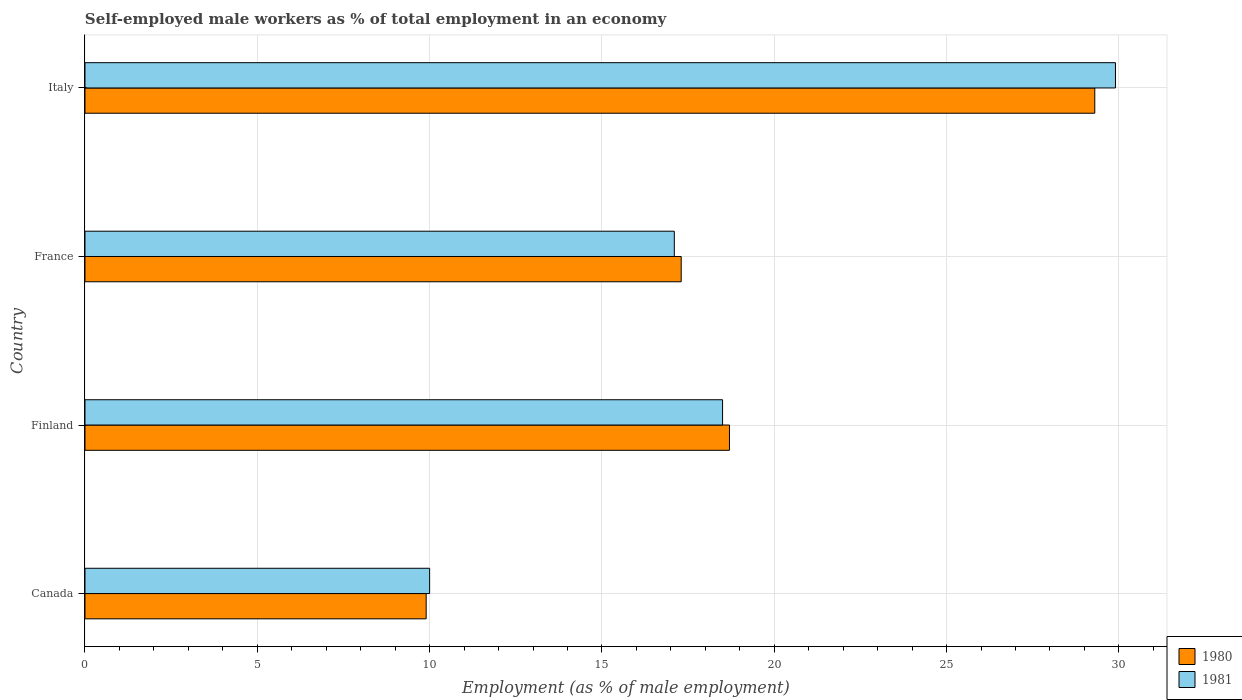How many different coloured bars are there?
Offer a terse response. 2. How many groups of bars are there?
Keep it short and to the point. 4. How many bars are there on the 2nd tick from the bottom?
Ensure brevity in your answer.  2. Across all countries, what is the maximum percentage of self-employed male workers in 1981?
Keep it short and to the point. 29.9. Across all countries, what is the minimum percentage of self-employed male workers in 1981?
Provide a short and direct response. 10. What is the total percentage of self-employed male workers in 1981 in the graph?
Offer a very short reply. 75.5. What is the difference between the percentage of self-employed male workers in 1981 in Canada and that in Finland?
Your response must be concise. -8.5. What is the difference between the percentage of self-employed male workers in 1981 in Italy and the percentage of self-employed male workers in 1980 in France?
Keep it short and to the point. 12.6. What is the average percentage of self-employed male workers in 1980 per country?
Your response must be concise. 18.8. What is the difference between the percentage of self-employed male workers in 1981 and percentage of self-employed male workers in 1980 in Canada?
Provide a short and direct response. 0.1. What is the ratio of the percentage of self-employed male workers in 1980 in Canada to that in France?
Ensure brevity in your answer.  0.57. What is the difference between the highest and the second highest percentage of self-employed male workers in 1980?
Offer a very short reply. 10.6. What is the difference between the highest and the lowest percentage of self-employed male workers in 1980?
Make the answer very short. 19.4. In how many countries, is the percentage of self-employed male workers in 1980 greater than the average percentage of self-employed male workers in 1980 taken over all countries?
Give a very brief answer. 1. Is the sum of the percentage of self-employed male workers in 1981 in Canada and Finland greater than the maximum percentage of self-employed male workers in 1980 across all countries?
Offer a terse response. No. What does the 1st bar from the top in France represents?
Offer a very short reply. 1981. How many countries are there in the graph?
Ensure brevity in your answer.  4. What is the difference between two consecutive major ticks on the X-axis?
Your response must be concise. 5. Are the values on the major ticks of X-axis written in scientific E-notation?
Offer a very short reply. No. Does the graph contain grids?
Offer a terse response. Yes. How are the legend labels stacked?
Offer a very short reply. Vertical. What is the title of the graph?
Keep it short and to the point. Self-employed male workers as % of total employment in an economy. Does "1990" appear as one of the legend labels in the graph?
Your answer should be compact. No. What is the label or title of the X-axis?
Offer a terse response. Employment (as % of male employment). What is the Employment (as % of male employment) of 1980 in Canada?
Offer a terse response. 9.9. What is the Employment (as % of male employment) in 1980 in Finland?
Your response must be concise. 18.7. What is the Employment (as % of male employment) in 1981 in Finland?
Keep it short and to the point. 18.5. What is the Employment (as % of male employment) of 1980 in France?
Ensure brevity in your answer.  17.3. What is the Employment (as % of male employment) of 1981 in France?
Provide a short and direct response. 17.1. What is the Employment (as % of male employment) in 1980 in Italy?
Your response must be concise. 29.3. What is the Employment (as % of male employment) in 1981 in Italy?
Ensure brevity in your answer.  29.9. Across all countries, what is the maximum Employment (as % of male employment) of 1980?
Offer a terse response. 29.3. Across all countries, what is the maximum Employment (as % of male employment) of 1981?
Your response must be concise. 29.9. Across all countries, what is the minimum Employment (as % of male employment) of 1980?
Your response must be concise. 9.9. What is the total Employment (as % of male employment) in 1980 in the graph?
Your response must be concise. 75.2. What is the total Employment (as % of male employment) of 1981 in the graph?
Ensure brevity in your answer.  75.5. What is the difference between the Employment (as % of male employment) of 1980 in Canada and that in France?
Give a very brief answer. -7.4. What is the difference between the Employment (as % of male employment) of 1981 in Canada and that in France?
Make the answer very short. -7.1. What is the difference between the Employment (as % of male employment) in 1980 in Canada and that in Italy?
Your answer should be compact. -19.4. What is the difference between the Employment (as % of male employment) of 1981 in Canada and that in Italy?
Offer a terse response. -19.9. What is the difference between the Employment (as % of male employment) in 1980 in Finland and that in Italy?
Ensure brevity in your answer.  -10.6. What is the difference between the Employment (as % of male employment) in 1981 in Finland and that in Italy?
Ensure brevity in your answer.  -11.4. What is the difference between the Employment (as % of male employment) in 1980 in France and that in Italy?
Provide a short and direct response. -12. What is the difference between the Employment (as % of male employment) in 1980 in Canada and the Employment (as % of male employment) in 1981 in Italy?
Your answer should be very brief. -20. What is the average Employment (as % of male employment) of 1981 per country?
Keep it short and to the point. 18.88. What is the difference between the Employment (as % of male employment) in 1980 and Employment (as % of male employment) in 1981 in Finland?
Offer a very short reply. 0.2. What is the difference between the Employment (as % of male employment) of 1980 and Employment (as % of male employment) of 1981 in France?
Make the answer very short. 0.2. What is the ratio of the Employment (as % of male employment) in 1980 in Canada to that in Finland?
Offer a very short reply. 0.53. What is the ratio of the Employment (as % of male employment) of 1981 in Canada to that in Finland?
Offer a terse response. 0.54. What is the ratio of the Employment (as % of male employment) of 1980 in Canada to that in France?
Your answer should be compact. 0.57. What is the ratio of the Employment (as % of male employment) of 1981 in Canada to that in France?
Your answer should be very brief. 0.58. What is the ratio of the Employment (as % of male employment) of 1980 in Canada to that in Italy?
Provide a short and direct response. 0.34. What is the ratio of the Employment (as % of male employment) in 1981 in Canada to that in Italy?
Provide a succinct answer. 0.33. What is the ratio of the Employment (as % of male employment) in 1980 in Finland to that in France?
Your response must be concise. 1.08. What is the ratio of the Employment (as % of male employment) in 1981 in Finland to that in France?
Your response must be concise. 1.08. What is the ratio of the Employment (as % of male employment) in 1980 in Finland to that in Italy?
Provide a succinct answer. 0.64. What is the ratio of the Employment (as % of male employment) in 1981 in Finland to that in Italy?
Make the answer very short. 0.62. What is the ratio of the Employment (as % of male employment) of 1980 in France to that in Italy?
Offer a very short reply. 0.59. What is the ratio of the Employment (as % of male employment) in 1981 in France to that in Italy?
Offer a terse response. 0.57. What is the difference between the highest and the second highest Employment (as % of male employment) in 1980?
Offer a very short reply. 10.6. What is the difference between the highest and the second highest Employment (as % of male employment) of 1981?
Keep it short and to the point. 11.4. What is the difference between the highest and the lowest Employment (as % of male employment) of 1980?
Give a very brief answer. 19.4. What is the difference between the highest and the lowest Employment (as % of male employment) of 1981?
Your answer should be very brief. 19.9. 